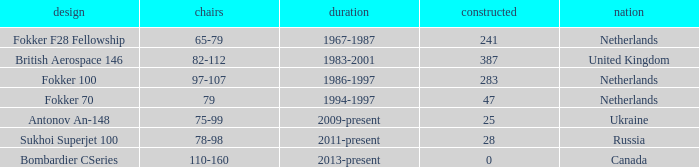How many cabins were built in the time between 1967-1987? 241.0. 